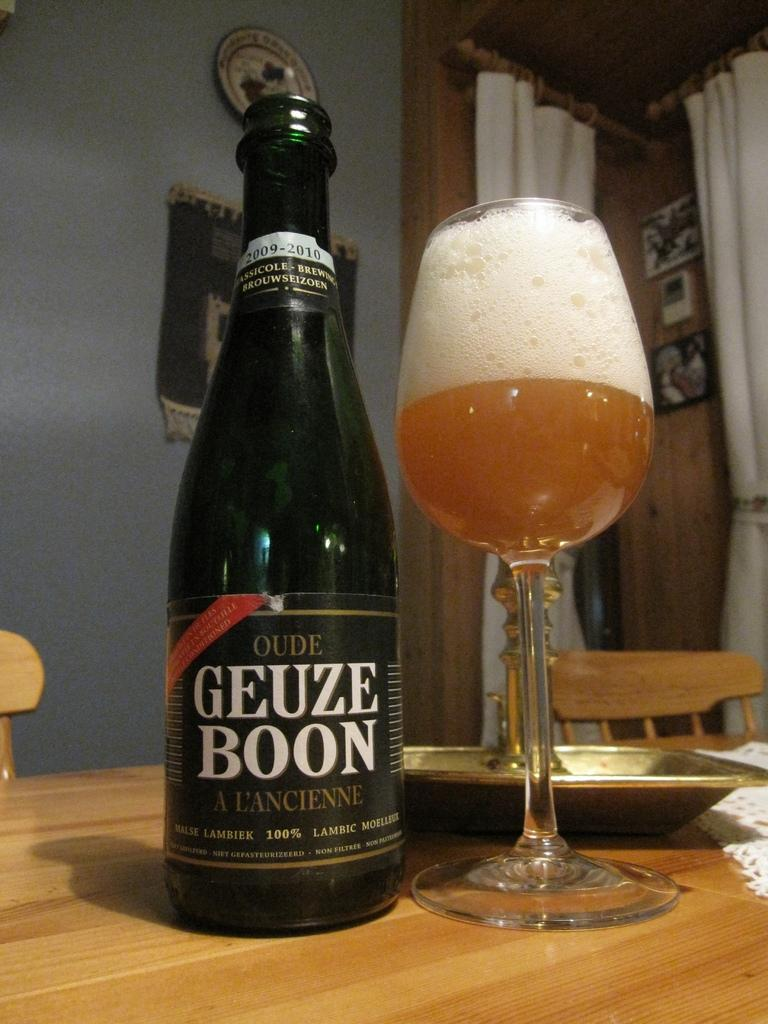<image>
Share a concise interpretation of the image provided. A tall wine glass is half full with beer and half full of foam, next to an opened bottle of Oude Geuze Boon on the table. 